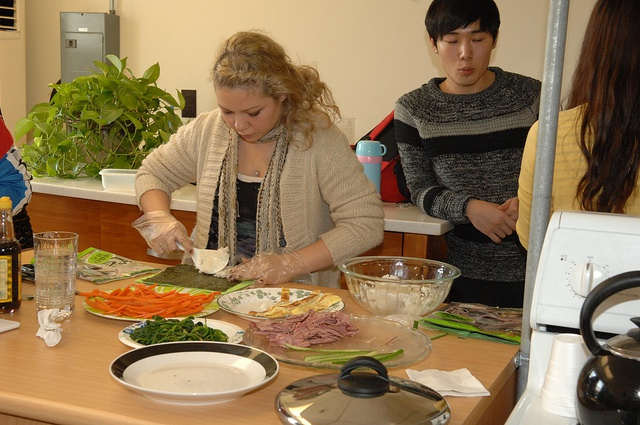Describe the objects in this image and their specific colors. I can see dining table in black, tan, gray, and olive tones, people in black, tan, gray, and maroon tones, people in black, maroon, gray, and brown tones, people in black, maroon, and tan tones, and potted plant in black and olive tones in this image. 